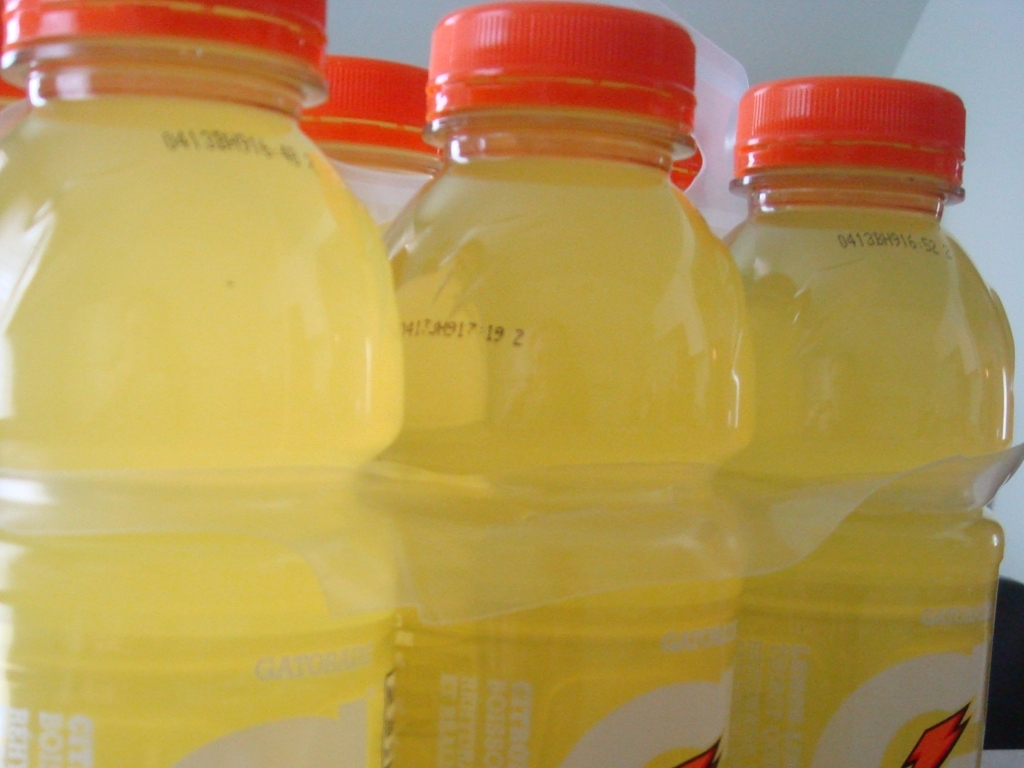Is the image clarity in this picture relatively high? The clarity of the image is decent, with the focus being on the three bottles in the foreground. Although there's a slight blurriness in the details, the text, liquid color inside the bottles, and brand logos are visible enough to discern without much difficulty. 